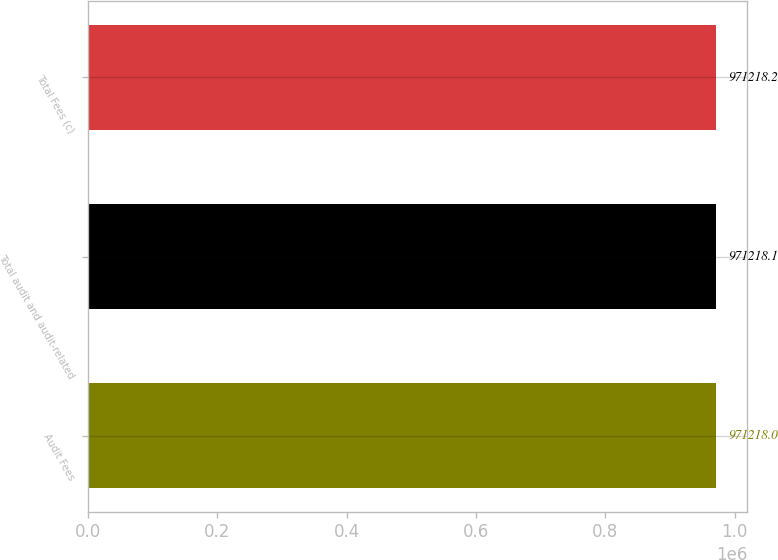Convert chart to OTSL. <chart><loc_0><loc_0><loc_500><loc_500><bar_chart><fcel>Audit Fees<fcel>Total audit and audit-related<fcel>Total Fees (c)<nl><fcel>971218<fcel>971218<fcel>971218<nl></chart> 